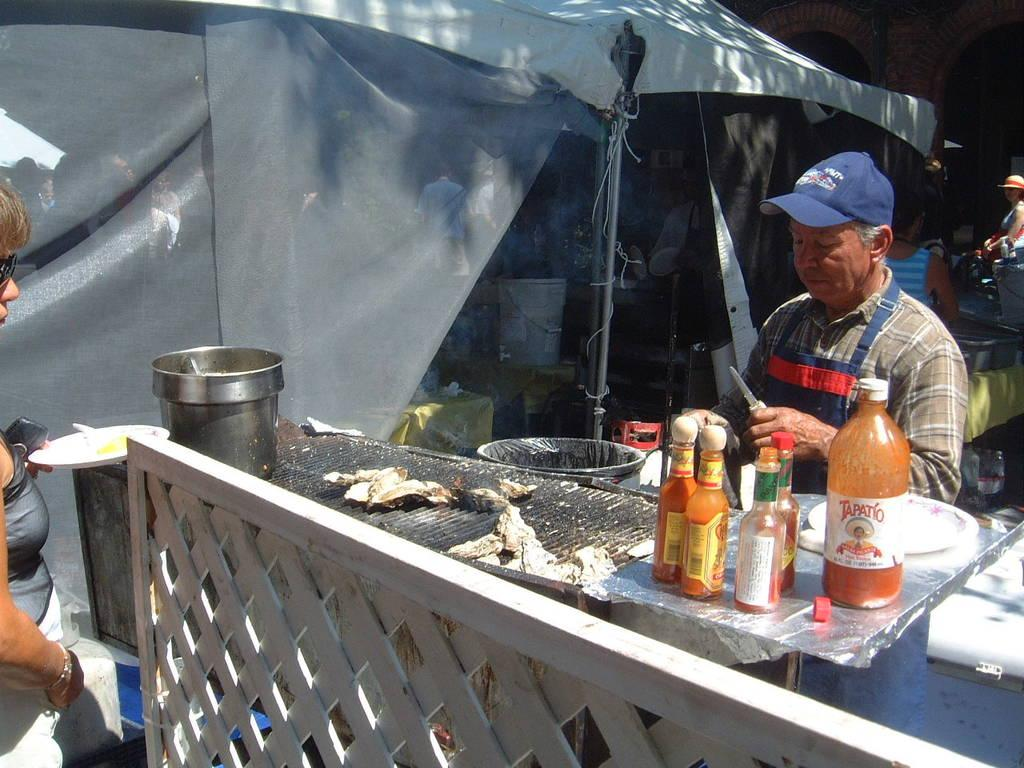What type of containers can be seen in the image? There are bottles and a bowl in the image. What other objects can be seen in the image? There are plates, a bucket, a tent, poles, caps, and goggles visible in the image. What type of furniture is present in the image? There is a table in the image. Are there any people in the image? Yes, there are people in the image. What can be seen in the background of the image? There are arches in the background of the image. Can you tell me how many toothbrushes are being used by the people in the image? There is no toothbrush present in the image, so it cannot be determined how many are being used. What type of egg is being cooked by the people in the image? There is no egg present in the image, so it cannot be determined what type of egg might be cooked. 